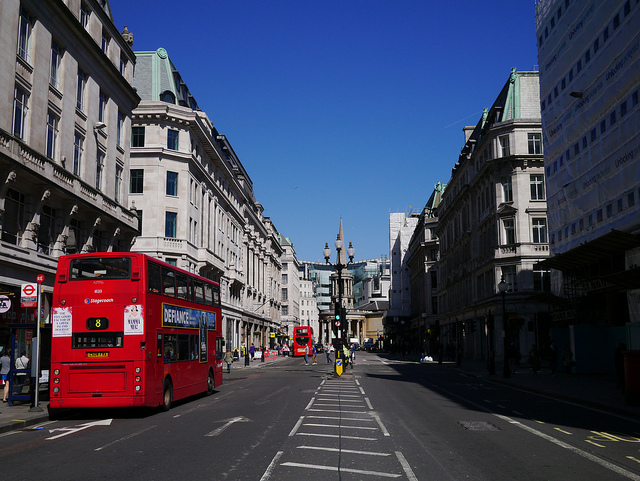How many double-decker buses are loading on the left side of the street? Upon examining the image, there are indeed two double-decker buses loading on the left side of the street. The distinctive red color and shape of these buses, which are a common sight in this city, make them easily identifiable even from a distance. 